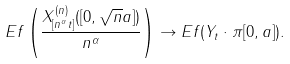Convert formula to latex. <formula><loc_0><loc_0><loc_500><loc_500>E f \left ( \frac { X _ { [ n ^ { \alpha } t ] } ^ { ( n ) } ( [ 0 , \sqrt { n } a ] ) } { n ^ { \alpha } } \right ) \to E f ( Y _ { t } \cdot \pi [ 0 , a ] ) .</formula> 